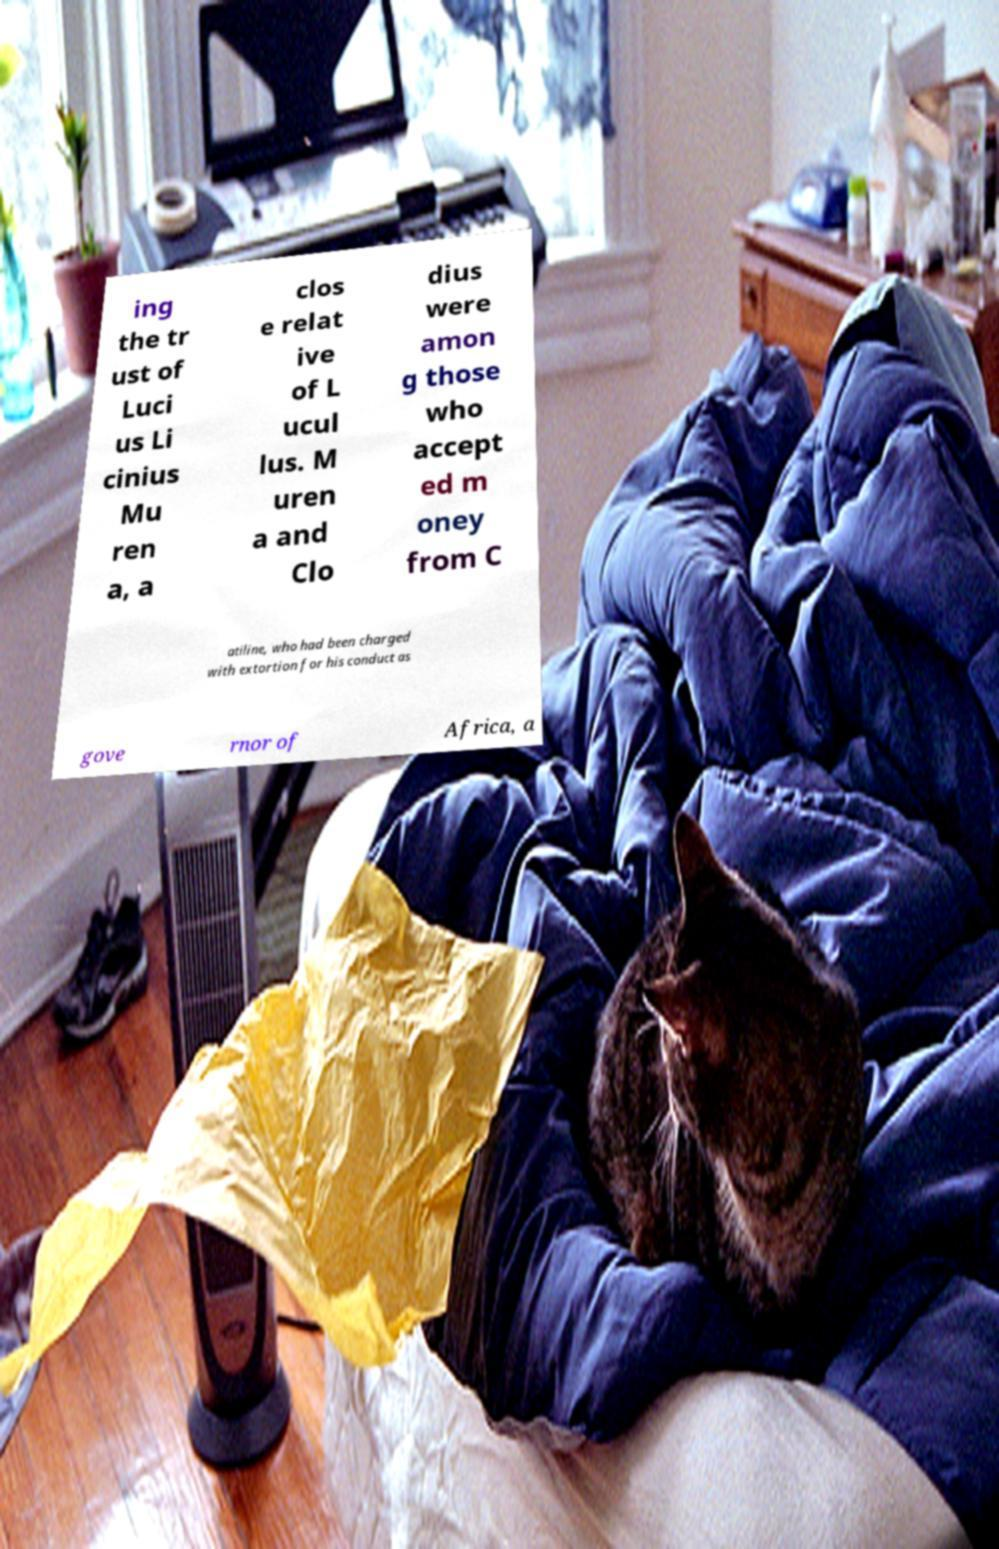Can you read and provide the text displayed in the image?This photo seems to have some interesting text. Can you extract and type it out for me? ing the tr ust of Luci us Li cinius Mu ren a, a clos e relat ive of L ucul lus. M uren a and Clo dius were amon g those who accept ed m oney from C atiline, who had been charged with extortion for his conduct as gove rnor of Africa, a 